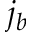Convert formula to latex. <formula><loc_0><loc_0><loc_500><loc_500>j _ { b }</formula> 